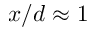<formula> <loc_0><loc_0><loc_500><loc_500>x / d \approx 1</formula> 